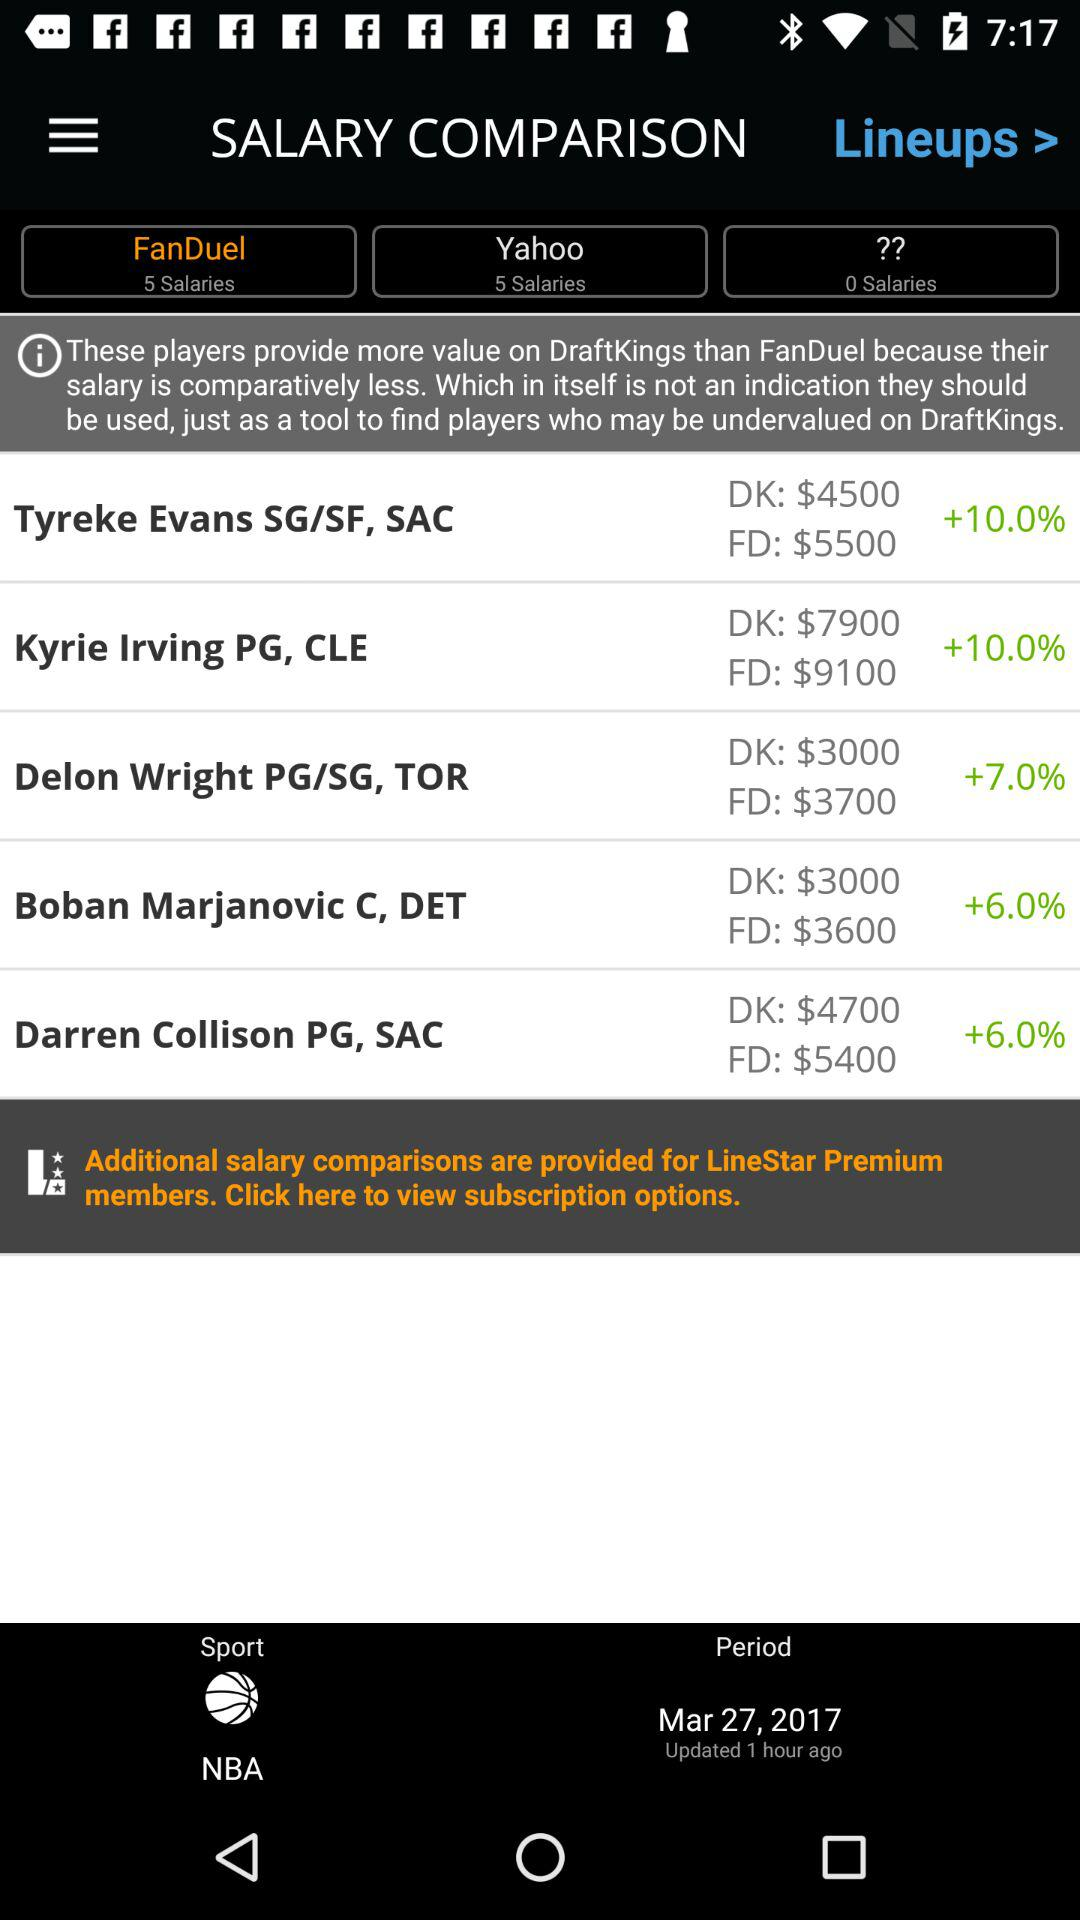What is the period date? The period date is March 27, 2017. 